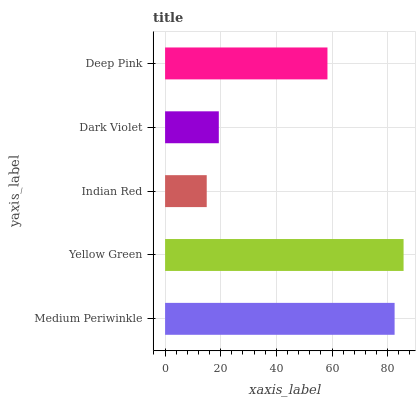Is Indian Red the minimum?
Answer yes or no. Yes. Is Yellow Green the maximum?
Answer yes or no. Yes. Is Yellow Green the minimum?
Answer yes or no. No. Is Indian Red the maximum?
Answer yes or no. No. Is Yellow Green greater than Indian Red?
Answer yes or no. Yes. Is Indian Red less than Yellow Green?
Answer yes or no. Yes. Is Indian Red greater than Yellow Green?
Answer yes or no. No. Is Yellow Green less than Indian Red?
Answer yes or no. No. Is Deep Pink the high median?
Answer yes or no. Yes. Is Deep Pink the low median?
Answer yes or no. Yes. Is Dark Violet the high median?
Answer yes or no. No. Is Dark Violet the low median?
Answer yes or no. No. 